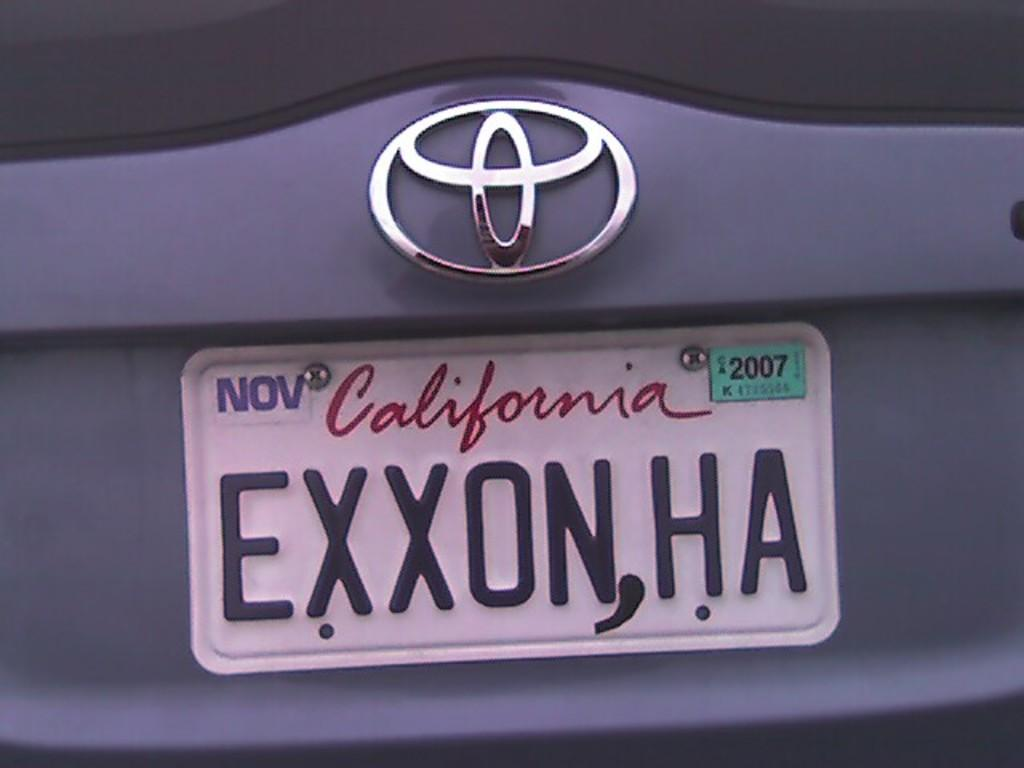Provide a one-sentence caption for the provided image. A Toyota with a license plate tagged in California with a registration expiring in November. 